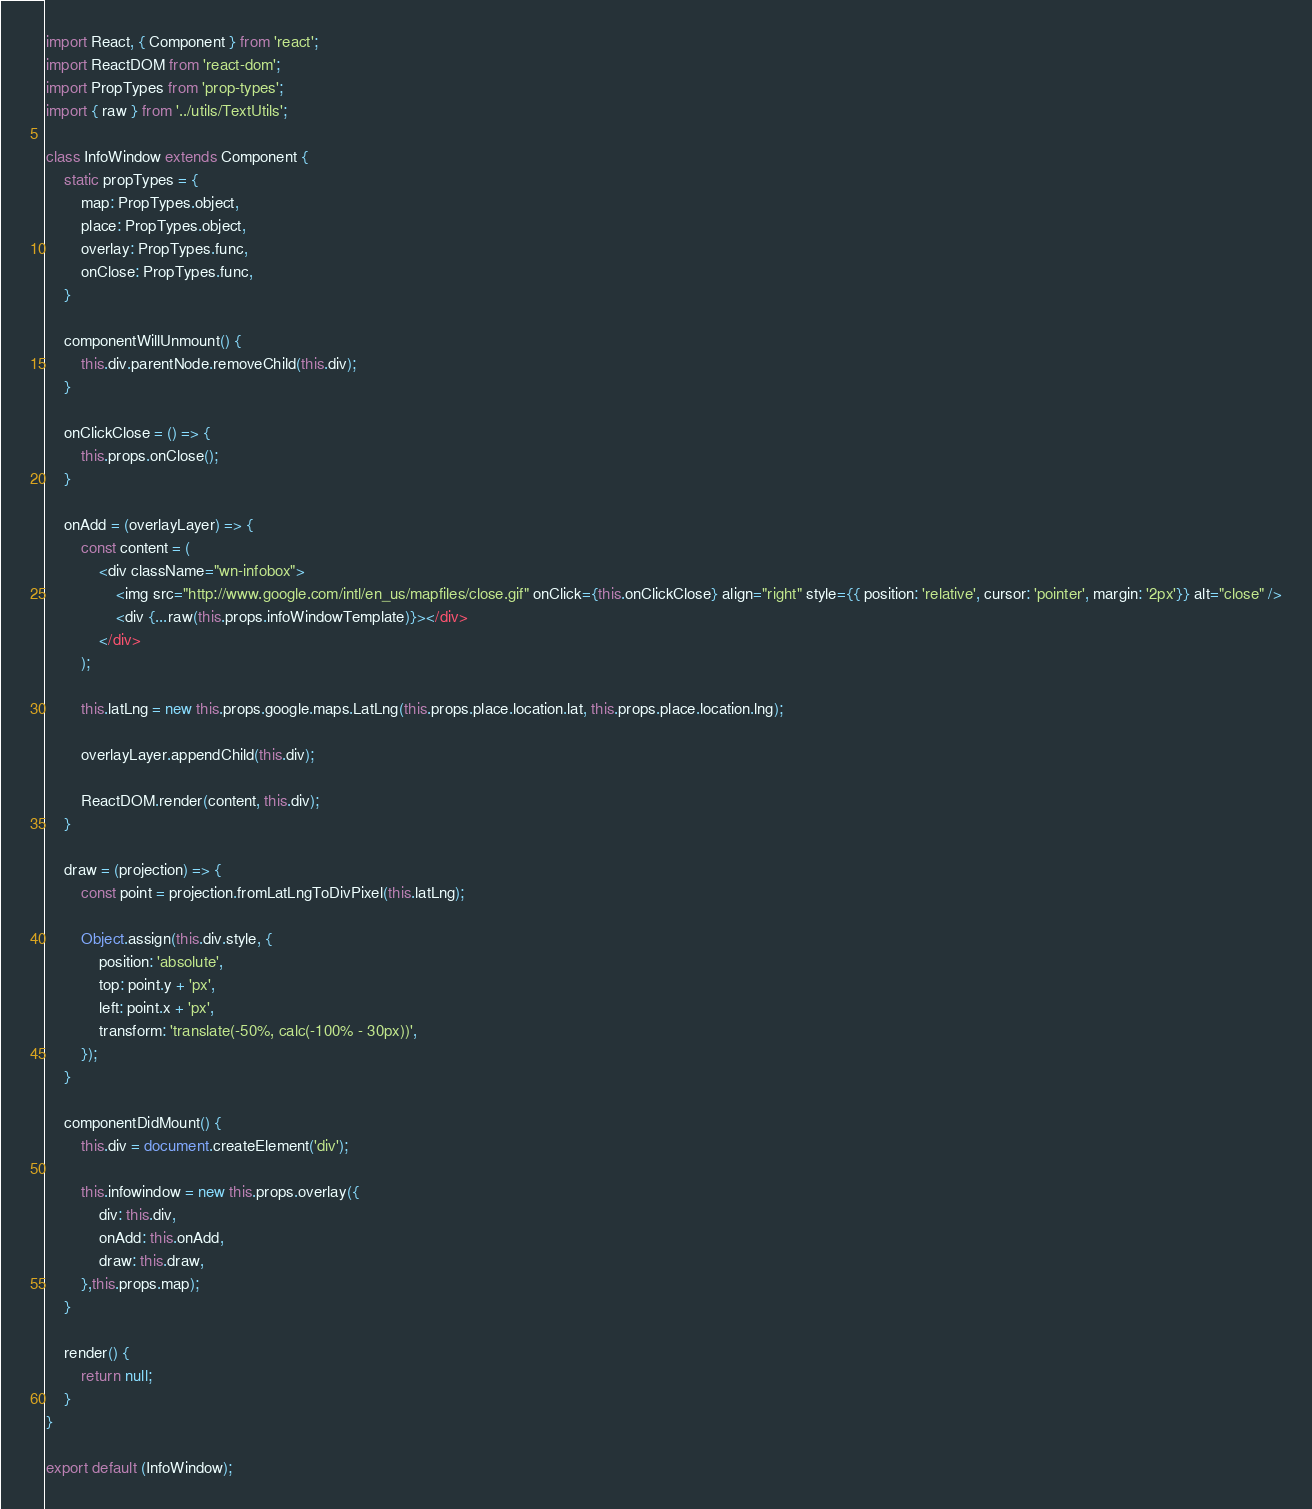<code> <loc_0><loc_0><loc_500><loc_500><_JavaScript_>import React, { Component } from 'react';
import ReactDOM from 'react-dom';
import PropTypes from 'prop-types';
import { raw } from '../utils/TextUtils';

class InfoWindow extends Component {
	static propTypes = {
		map: PropTypes.object,
		place: PropTypes.object,
		overlay: PropTypes.func,
		onClose: PropTypes.func,
	}

	componentWillUnmount() {
		this.div.parentNode.removeChild(this.div);
	}

	onClickClose = () => {
		this.props.onClose();
	}

	onAdd = (overlayLayer) => {
		const content = (
			<div className="wn-infobox">
				<img src="http://www.google.com/intl/en_us/mapfiles/close.gif" onClick={this.onClickClose} align="right" style={{ position: 'relative', cursor: 'pointer', margin: '2px'}} alt="close" />
				<div {...raw(this.props.infoWindowTemplate)}></div>
			</div>
		);

		this.latLng = new this.props.google.maps.LatLng(this.props.place.location.lat, this.props.place.location.lng);

		overlayLayer.appendChild(this.div);

		ReactDOM.render(content, this.div);
	}

	draw = (projection) => {
		const point = projection.fromLatLngToDivPixel(this.latLng);

		Object.assign(this.div.style, {
			position: 'absolute',
			top: point.y + 'px',
			left: point.x + 'px',
			transform: 'translate(-50%, calc(-100% - 30px))',
		});
	}

	componentDidMount() {
		this.div = document.createElement('div');

		this.infowindow = new this.props.overlay({
			div: this.div,
			onAdd: this.onAdd,
			draw: this.draw,
		},this.props.map);
	}

	render() {
		return null;
	}
}

export default (InfoWindow);</code> 